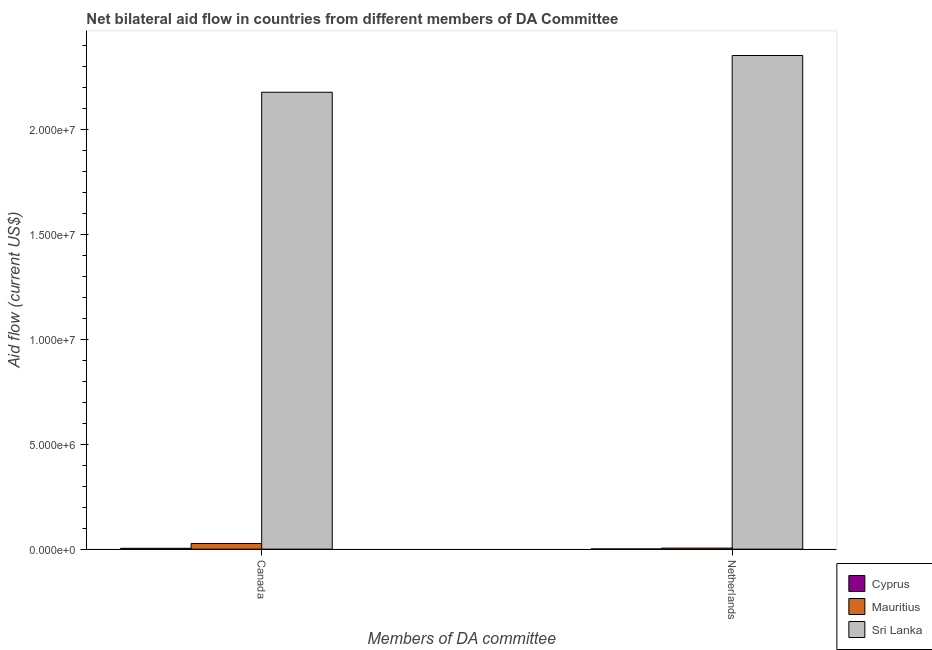How many different coloured bars are there?
Your answer should be very brief. 3. Are the number of bars per tick equal to the number of legend labels?
Make the answer very short. Yes. Are the number of bars on each tick of the X-axis equal?
Provide a succinct answer. Yes. How many bars are there on the 1st tick from the right?
Offer a very short reply. 3. What is the label of the 1st group of bars from the left?
Give a very brief answer. Canada. What is the amount of aid given by netherlands in Sri Lanka?
Your response must be concise. 2.35e+07. Across all countries, what is the maximum amount of aid given by netherlands?
Make the answer very short. 2.35e+07. Across all countries, what is the minimum amount of aid given by netherlands?
Your response must be concise. 10000. In which country was the amount of aid given by netherlands maximum?
Your answer should be very brief. Sri Lanka. In which country was the amount of aid given by canada minimum?
Provide a short and direct response. Cyprus. What is the total amount of aid given by netherlands in the graph?
Ensure brevity in your answer.  2.36e+07. What is the difference between the amount of aid given by canada in Cyprus and that in Sri Lanka?
Your response must be concise. -2.17e+07. What is the difference between the amount of aid given by canada in Mauritius and the amount of aid given by netherlands in Cyprus?
Make the answer very short. 2.60e+05. What is the average amount of aid given by netherlands per country?
Give a very brief answer. 7.86e+06. What is the difference between the amount of aid given by netherlands and amount of aid given by canada in Sri Lanka?
Your answer should be compact. 1.75e+06. In how many countries, is the amount of aid given by netherlands greater than 16000000 US$?
Provide a short and direct response. 1. What is the ratio of the amount of aid given by netherlands in Cyprus to that in Sri Lanka?
Provide a short and direct response. 0. Is the amount of aid given by canada in Sri Lanka less than that in Mauritius?
Your response must be concise. No. In how many countries, is the amount of aid given by canada greater than the average amount of aid given by canada taken over all countries?
Provide a succinct answer. 1. What does the 3rd bar from the left in Canada represents?
Keep it short and to the point. Sri Lanka. What does the 3rd bar from the right in Netherlands represents?
Make the answer very short. Cyprus. What is the difference between two consecutive major ticks on the Y-axis?
Your answer should be very brief. 5.00e+06. Are the values on the major ticks of Y-axis written in scientific E-notation?
Your answer should be very brief. Yes. Does the graph contain any zero values?
Provide a succinct answer. No. Does the graph contain grids?
Keep it short and to the point. No. What is the title of the graph?
Provide a succinct answer. Net bilateral aid flow in countries from different members of DA Committee. Does "Uruguay" appear as one of the legend labels in the graph?
Your answer should be compact. No. What is the label or title of the X-axis?
Provide a short and direct response. Members of DA committee. What is the label or title of the Y-axis?
Make the answer very short. Aid flow (current US$). What is the Aid flow (current US$) in Mauritius in Canada?
Offer a very short reply. 2.70e+05. What is the Aid flow (current US$) in Sri Lanka in Canada?
Your response must be concise. 2.18e+07. What is the Aid flow (current US$) of Sri Lanka in Netherlands?
Keep it short and to the point. 2.35e+07. Across all Members of DA committee, what is the maximum Aid flow (current US$) of Cyprus?
Provide a short and direct response. 4.00e+04. Across all Members of DA committee, what is the maximum Aid flow (current US$) of Mauritius?
Your response must be concise. 2.70e+05. Across all Members of DA committee, what is the maximum Aid flow (current US$) of Sri Lanka?
Your answer should be very brief. 2.35e+07. Across all Members of DA committee, what is the minimum Aid flow (current US$) in Sri Lanka?
Your answer should be compact. 2.18e+07. What is the total Aid flow (current US$) in Mauritius in the graph?
Ensure brevity in your answer.  3.20e+05. What is the total Aid flow (current US$) in Sri Lanka in the graph?
Ensure brevity in your answer.  4.53e+07. What is the difference between the Aid flow (current US$) of Cyprus in Canada and that in Netherlands?
Ensure brevity in your answer.  3.00e+04. What is the difference between the Aid flow (current US$) of Sri Lanka in Canada and that in Netherlands?
Make the answer very short. -1.75e+06. What is the difference between the Aid flow (current US$) of Cyprus in Canada and the Aid flow (current US$) of Sri Lanka in Netherlands?
Give a very brief answer. -2.35e+07. What is the difference between the Aid flow (current US$) of Mauritius in Canada and the Aid flow (current US$) of Sri Lanka in Netherlands?
Ensure brevity in your answer.  -2.32e+07. What is the average Aid flow (current US$) of Cyprus per Members of DA committee?
Keep it short and to the point. 2.50e+04. What is the average Aid flow (current US$) of Mauritius per Members of DA committee?
Make the answer very short. 1.60e+05. What is the average Aid flow (current US$) in Sri Lanka per Members of DA committee?
Your response must be concise. 2.26e+07. What is the difference between the Aid flow (current US$) of Cyprus and Aid flow (current US$) of Mauritius in Canada?
Keep it short and to the point. -2.30e+05. What is the difference between the Aid flow (current US$) in Cyprus and Aid flow (current US$) in Sri Lanka in Canada?
Provide a short and direct response. -2.17e+07. What is the difference between the Aid flow (current US$) in Mauritius and Aid flow (current US$) in Sri Lanka in Canada?
Offer a terse response. -2.15e+07. What is the difference between the Aid flow (current US$) of Cyprus and Aid flow (current US$) of Sri Lanka in Netherlands?
Provide a short and direct response. -2.35e+07. What is the difference between the Aid flow (current US$) in Mauritius and Aid flow (current US$) in Sri Lanka in Netherlands?
Your response must be concise. -2.35e+07. What is the ratio of the Aid flow (current US$) in Mauritius in Canada to that in Netherlands?
Offer a very short reply. 5.4. What is the ratio of the Aid flow (current US$) in Sri Lanka in Canada to that in Netherlands?
Your answer should be compact. 0.93. What is the difference between the highest and the second highest Aid flow (current US$) of Cyprus?
Offer a terse response. 3.00e+04. What is the difference between the highest and the second highest Aid flow (current US$) in Sri Lanka?
Make the answer very short. 1.75e+06. What is the difference between the highest and the lowest Aid flow (current US$) in Cyprus?
Give a very brief answer. 3.00e+04. What is the difference between the highest and the lowest Aid flow (current US$) in Sri Lanka?
Your response must be concise. 1.75e+06. 